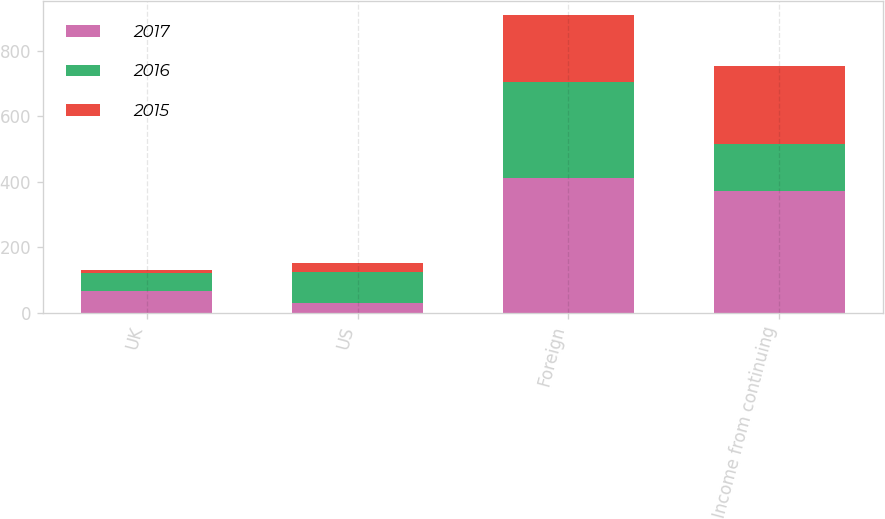Convert chart. <chart><loc_0><loc_0><loc_500><loc_500><stacked_bar_chart><ecel><fcel>UK<fcel>US<fcel>Foreign<fcel>Income from continuing<nl><fcel>2017<fcel>67<fcel>28.7<fcel>410.4<fcel>372.1<nl><fcel>2016<fcel>55.4<fcel>96.4<fcel>294.1<fcel>142.3<nl><fcel>2015<fcel>8.9<fcel>26.1<fcel>202.8<fcel>237.8<nl></chart> 